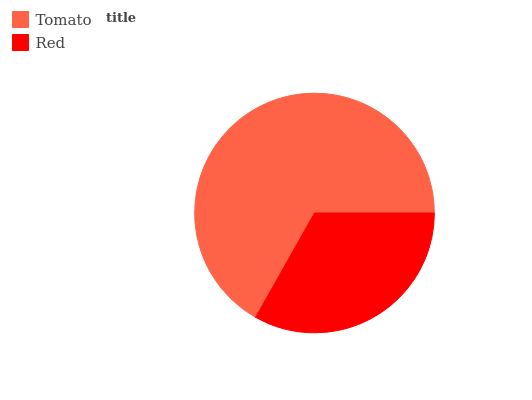Is Red the minimum?
Answer yes or no. Yes. Is Tomato the maximum?
Answer yes or no. Yes. Is Red the maximum?
Answer yes or no. No. Is Tomato greater than Red?
Answer yes or no. Yes. Is Red less than Tomato?
Answer yes or no. Yes. Is Red greater than Tomato?
Answer yes or no. No. Is Tomato less than Red?
Answer yes or no. No. Is Tomato the high median?
Answer yes or no. Yes. Is Red the low median?
Answer yes or no. Yes. Is Red the high median?
Answer yes or no. No. Is Tomato the low median?
Answer yes or no. No. 